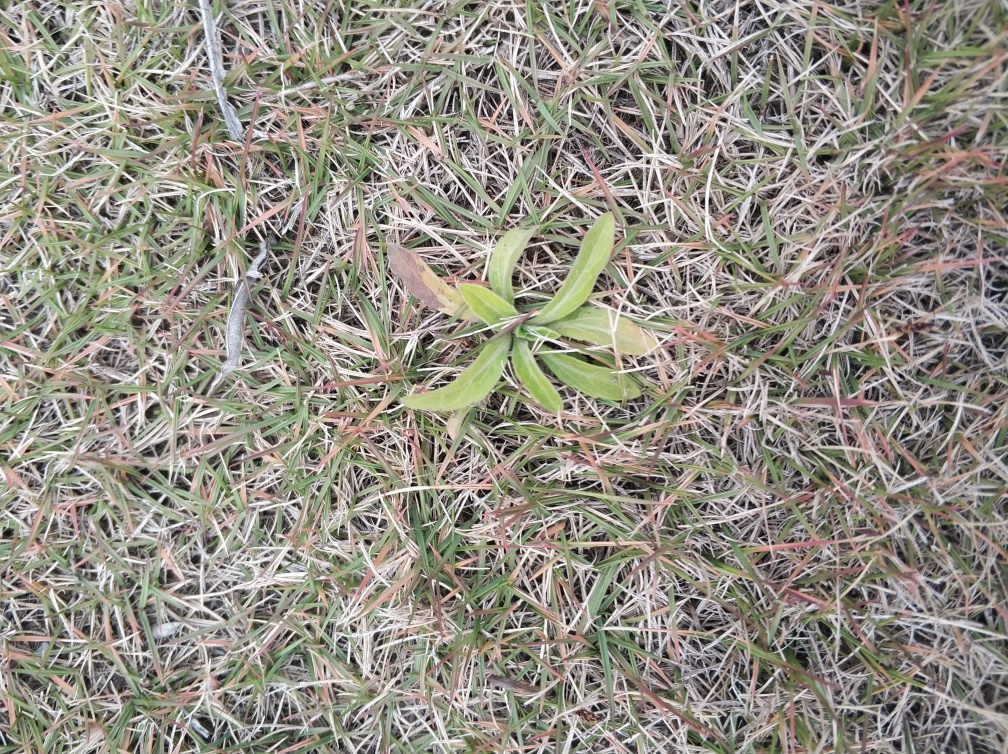Is this type of grass beneficial for the ecosystem? Grasses like the ones shown in the image are often important for the ecosystem. They can prevent soil erosion, support biodiversity by providing habitat for numerous insects and small animals, and contribute to the carbon cycle as they absorb carbon dioxide during photosynthesis.  What activities could this place be used for? The area depicted in the image, with its grassy ground cover, could serve a variety of recreational purposes: it could be used for picnics, sports, and leisure activities or simply as a space for relaxation and connection with nature. 